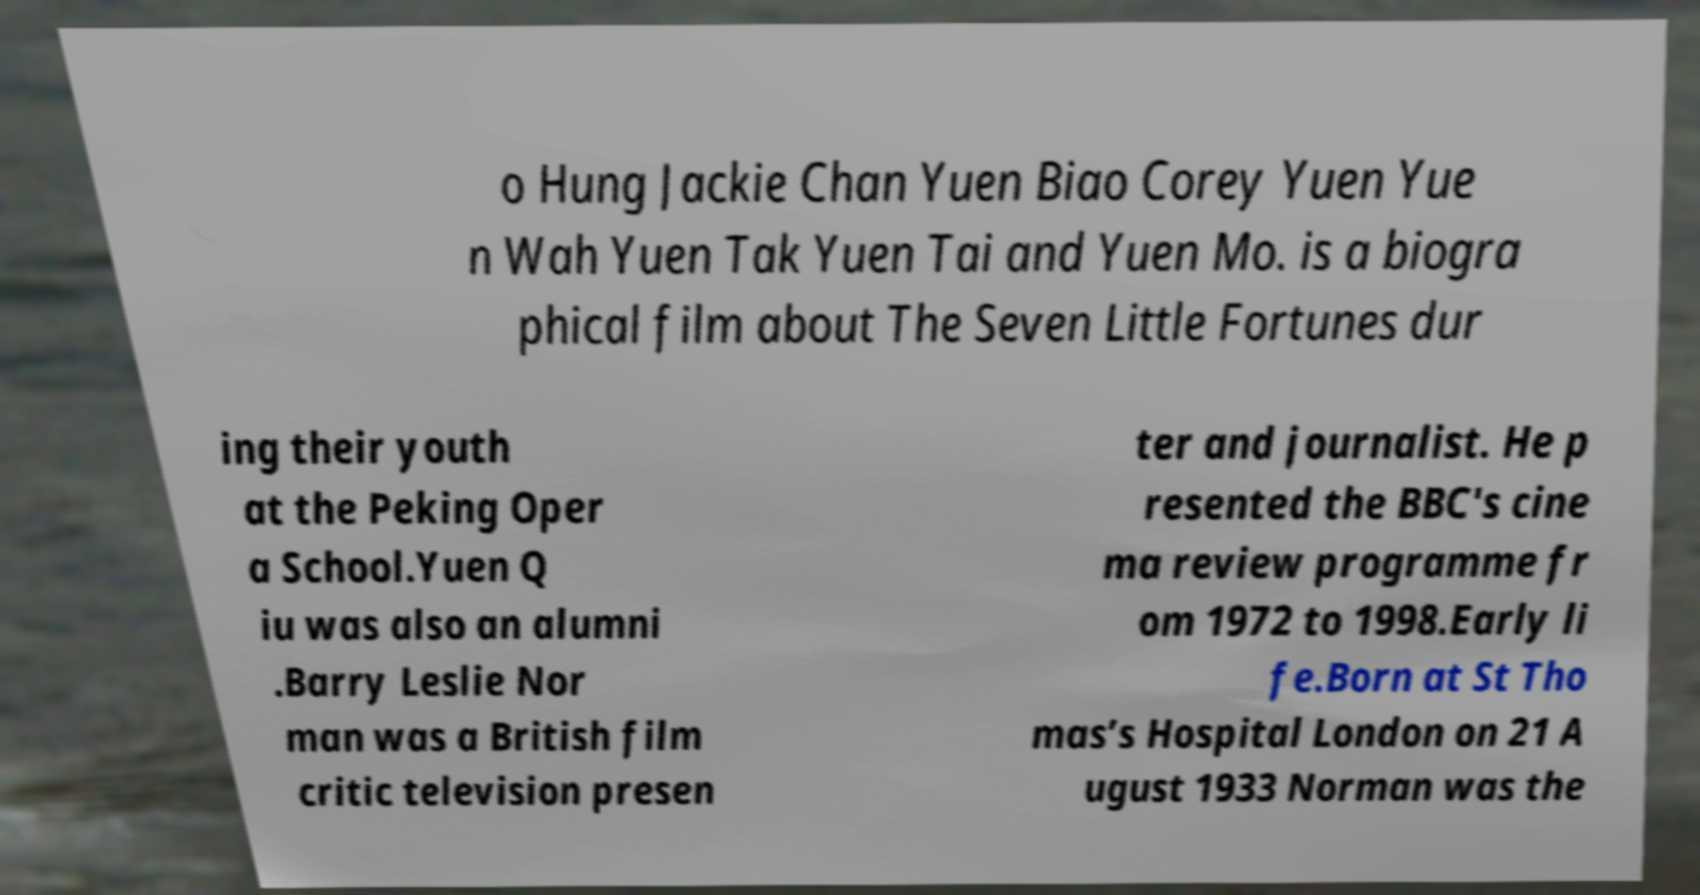Could you extract and type out the text from this image? o Hung Jackie Chan Yuen Biao Corey Yuen Yue n Wah Yuen Tak Yuen Tai and Yuen Mo. is a biogra phical film about The Seven Little Fortunes dur ing their youth at the Peking Oper a School.Yuen Q iu was also an alumni .Barry Leslie Nor man was a British film critic television presen ter and journalist. He p resented the BBC's cine ma review programme fr om 1972 to 1998.Early li fe.Born at St Tho mas’s Hospital London on 21 A ugust 1933 Norman was the 